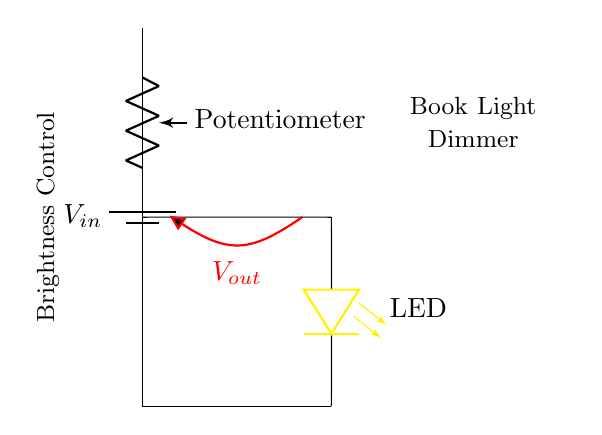What is the input voltage in the circuit? The input voltage is labeled as \( V_{in} \) and is indicated by the battery symbol at the top of the diagram.
Answer: \( V_{in} \) What component regulates brightness in this circuit? The component that regulates brightness is the potentiometer, shown between the battery and the LED in the circuit.
Answer: Potentiometer What is the color of the LED used in the circuit? The LED is specifically labeled with the color yellow in the circuit diagram.
Answer: Yellow What is the purpose of the potentiometer in the circuit? The purpose of the potentiometer is to act as a variable resistor, allowing for adjustment of the output voltage, which dims the LED.
Answer: Brightness control How does changing the potentiometer affect the LED? Changing the resistance of the potentiometer alters the voltage drop across it, which consequently changes the brightness of the LED based on the voltage supplied to it.
Answer: Alters brightness How many main components are present in this circuit? The circuit includes three main components: a battery, a potentiometer, and an LED.
Answer: Three What is the output voltage in relation to the configuration of the circuit? The output voltage, labeled as \( V_{out} \), is the voltage across the LED, which is dependent on the setting of the potentiometer and the input voltage.
Answer: \( V_{out} \) 